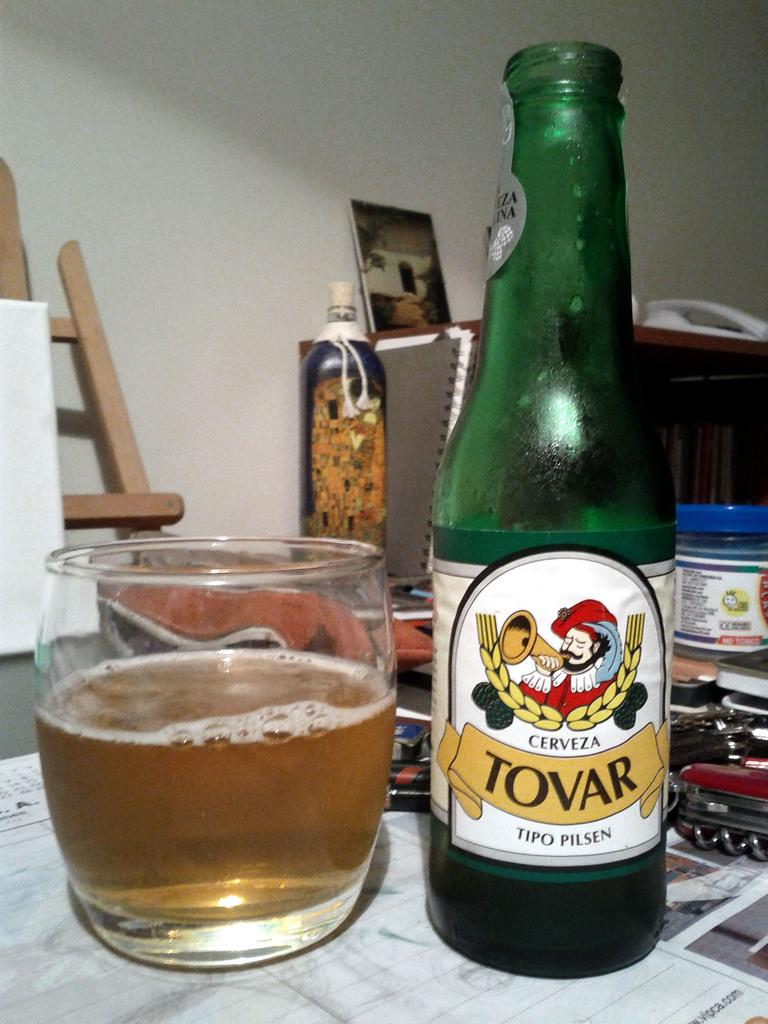What piece of furniture is present in the image? There is a table in the image. What is placed on the table? There is a cup and a bottle on the table. What can be seen in the background of the image? There is a photo frame visible in the background, and there is a wall in the background. How many bikes are parked next to the table in the image? There are no bikes present in the image. Who is the representative of the group in the image? There is no group or representative mentioned in the image. 